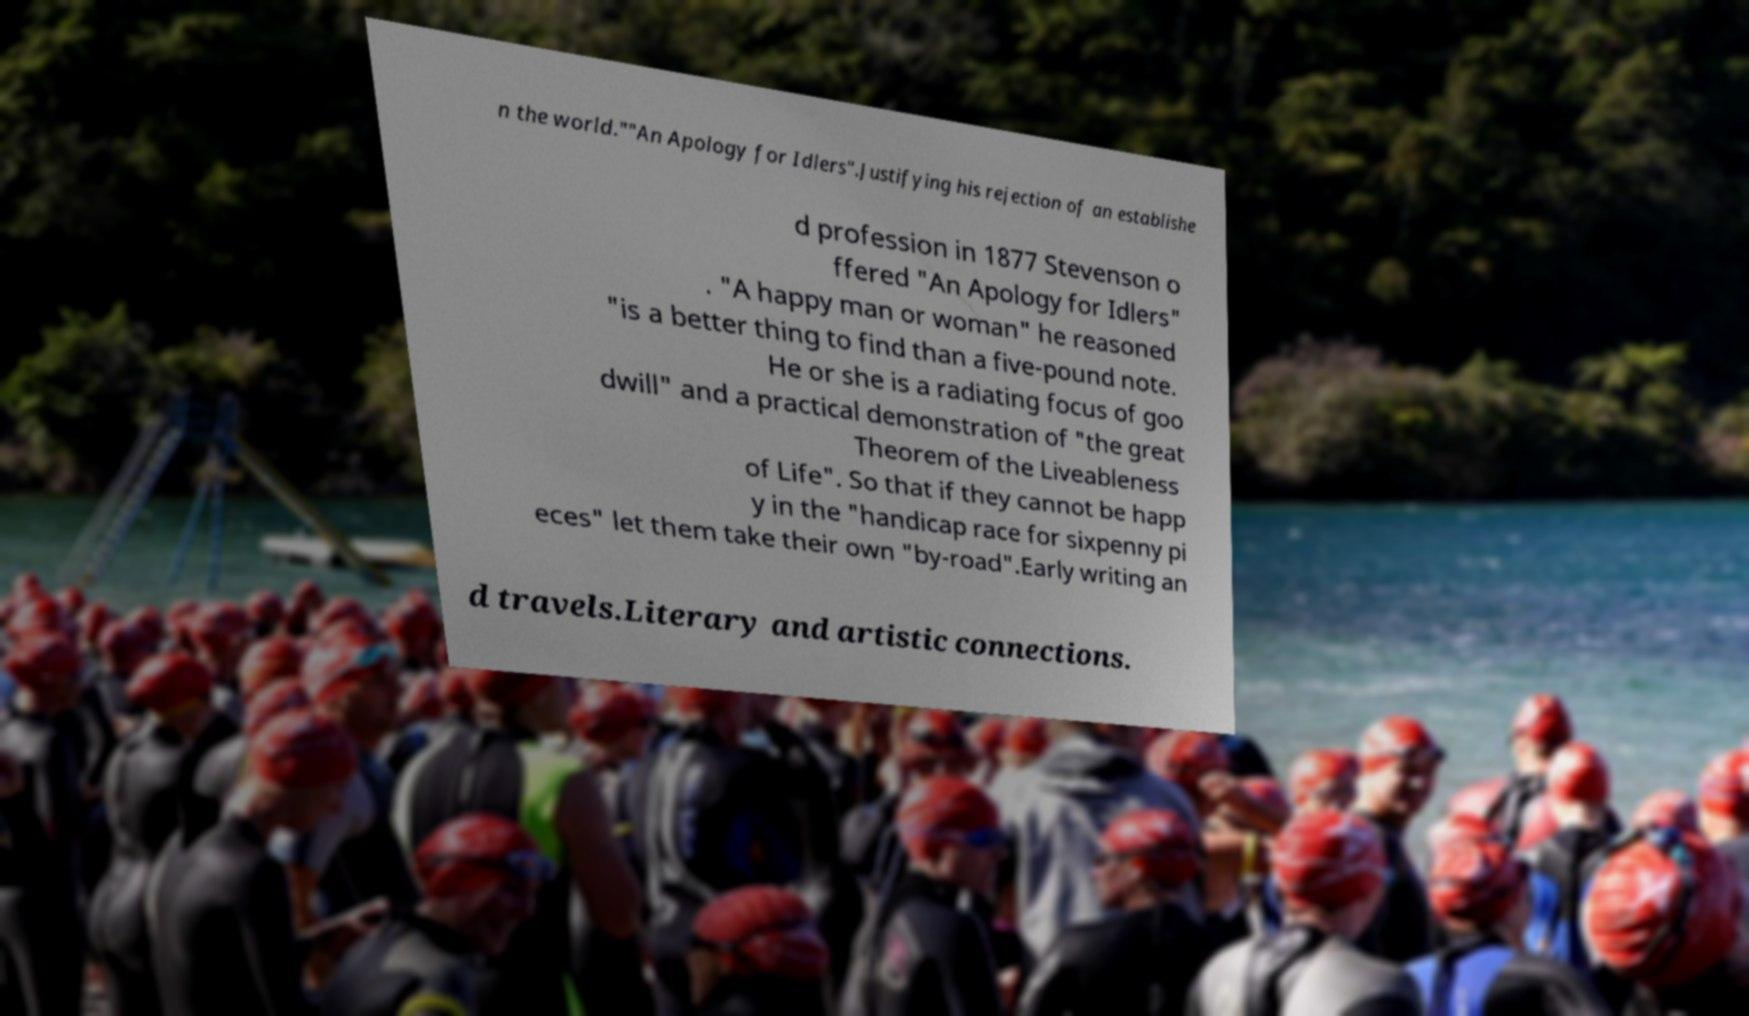There's text embedded in this image that I need extracted. Can you transcribe it verbatim? n the world.""An Apology for Idlers".Justifying his rejection of an establishe d profession in 1877 Stevenson o ffered "An Apology for Idlers" . "A happy man or woman" he reasoned "is a better thing to find than a five-pound note. He or she is a radiating focus of goo dwill" and a practical demonstration of "the great Theorem of the Liveableness of Life". So that if they cannot be happ y in the "handicap race for sixpenny pi eces" let them take their own "by-road".Early writing an d travels.Literary and artistic connections. 